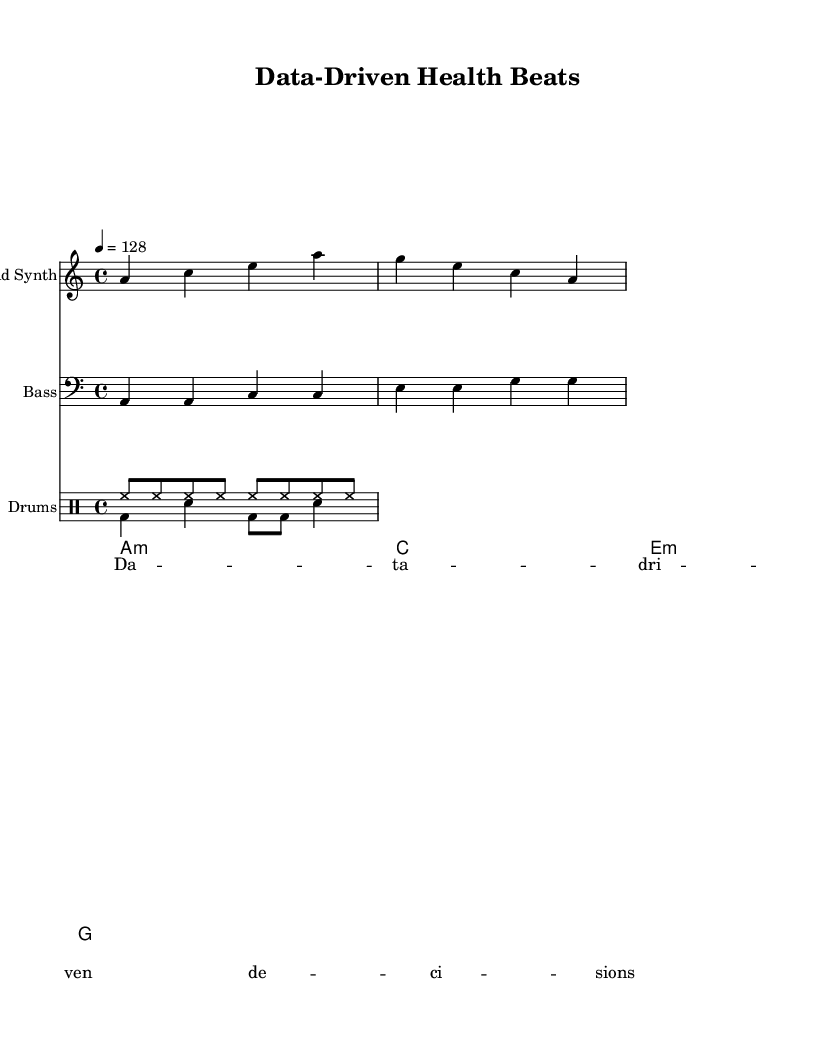What is the key signature of this music? The key signature is indicated by the presence of the notes in the lead synth part, specifically in the global declaration where it states \key a \minor, meaning it has one flat.
Answer: A minor What is the time signature of this music? The time signature is found in the global context of the score indicated by \time 4/4, which means there are four beats in each measure, and the quarter note gets the beat.
Answer: 4/4 What is the tempo marking for this composition? The tempo marking appears in the global context and is given as \tempo 4 = 128, indicating that there are 128 beats per minute.
Answer: 128 How many notes are in the bass line? By counting the notes in the bass voice which are listed, we can see that there are eight quarters present in the bass part.
Answer: Eight What is the rhythmic pattern of the drums during the 'drumsUp' section? The 'drumsUp' section shows a repetitive pattern of hi-hat where it is indicated as hihat eight times followed by hihat one more time, totaling eight hi-hat hits.
Answer: Eight Which lyric phrase accompanies the music? The lyrics are displayed under the music in the Lyrics section, where it clearly states 'Data-driven decisions', indicating the message to be conveyed with the jingle.
Answer: Data-driven decisions What type of synthesizer is indicated in the score? The instrument named "Lead Synth" appears at the beginning of the corresponding Staff and indicates that the lead synthesizer is being used in this part.
Answer: Lead Synth 